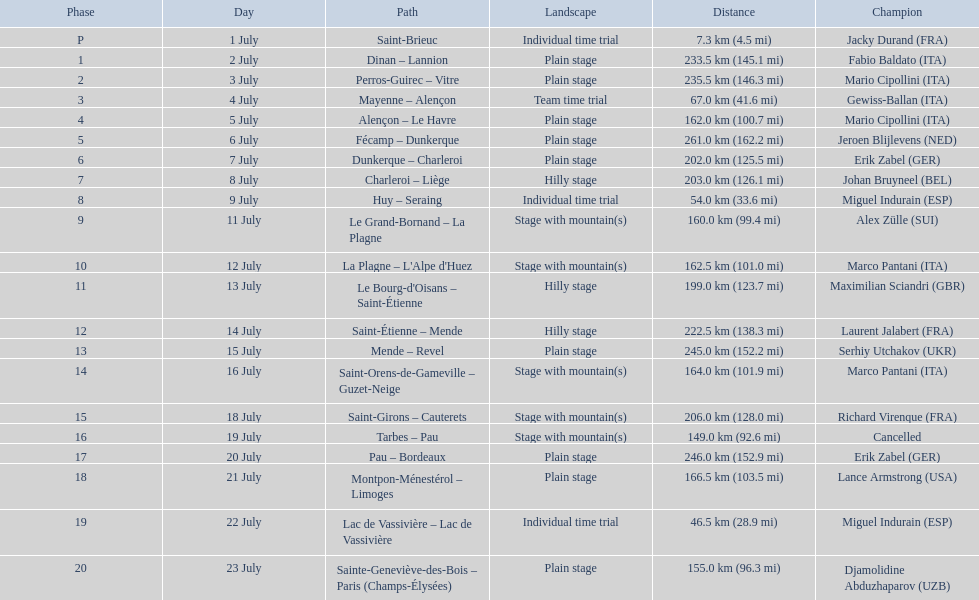Which country had more stage-winners than any other country? Italy. 